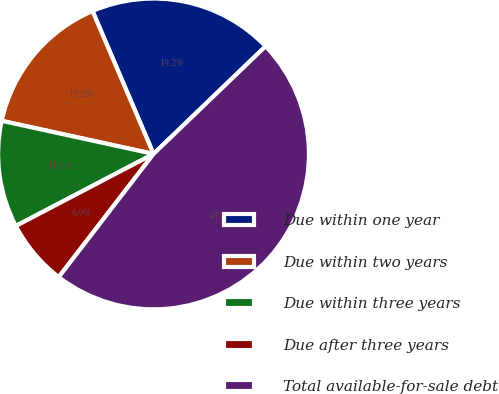<chart> <loc_0><loc_0><loc_500><loc_500><pie_chart><fcel>Due within one year<fcel>Due within two years<fcel>Due within three years<fcel>Due after three years<fcel>Total available-for-sale debt<nl><fcel>19.24%<fcel>15.16%<fcel>11.09%<fcel>6.89%<fcel>47.63%<nl></chart> 